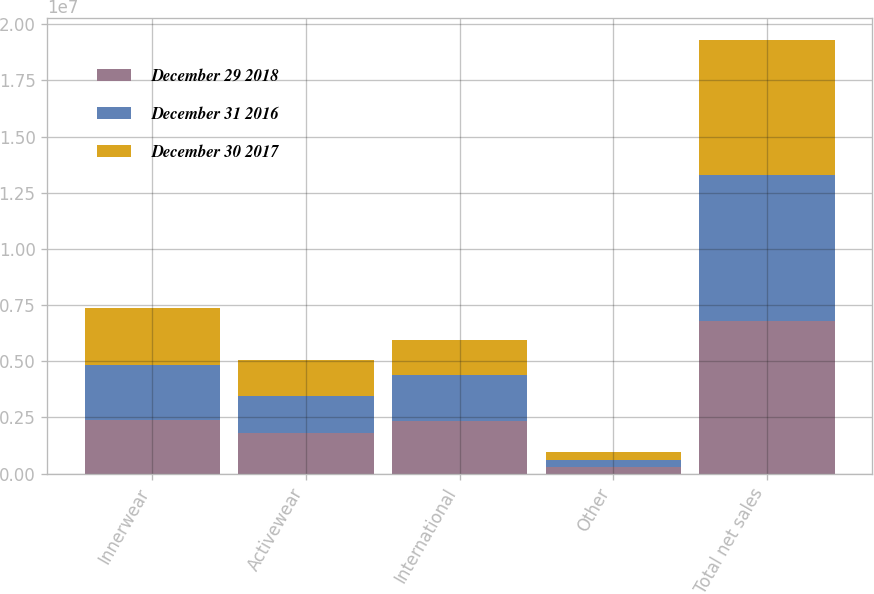<chart> <loc_0><loc_0><loc_500><loc_500><stacked_bar_chart><ecel><fcel>Innerwear<fcel>Activewear<fcel>International<fcel>Other<fcel>Total net sales<nl><fcel>December 29 2018<fcel>2.37968e+06<fcel>1.79228e+06<fcel>2.34412e+06<fcel>287885<fcel>6.80396e+06<nl><fcel>December 31 2016<fcel>2.46288e+06<fcel>1.65428e+06<fcel>2.05466e+06<fcel>299592<fcel>6.47141e+06<nl><fcel>December 30 2017<fcel>2.54372e+06<fcel>1.60111e+06<fcel>1.53191e+06<fcel>351461<fcel>6.0282e+06<nl></chart> 